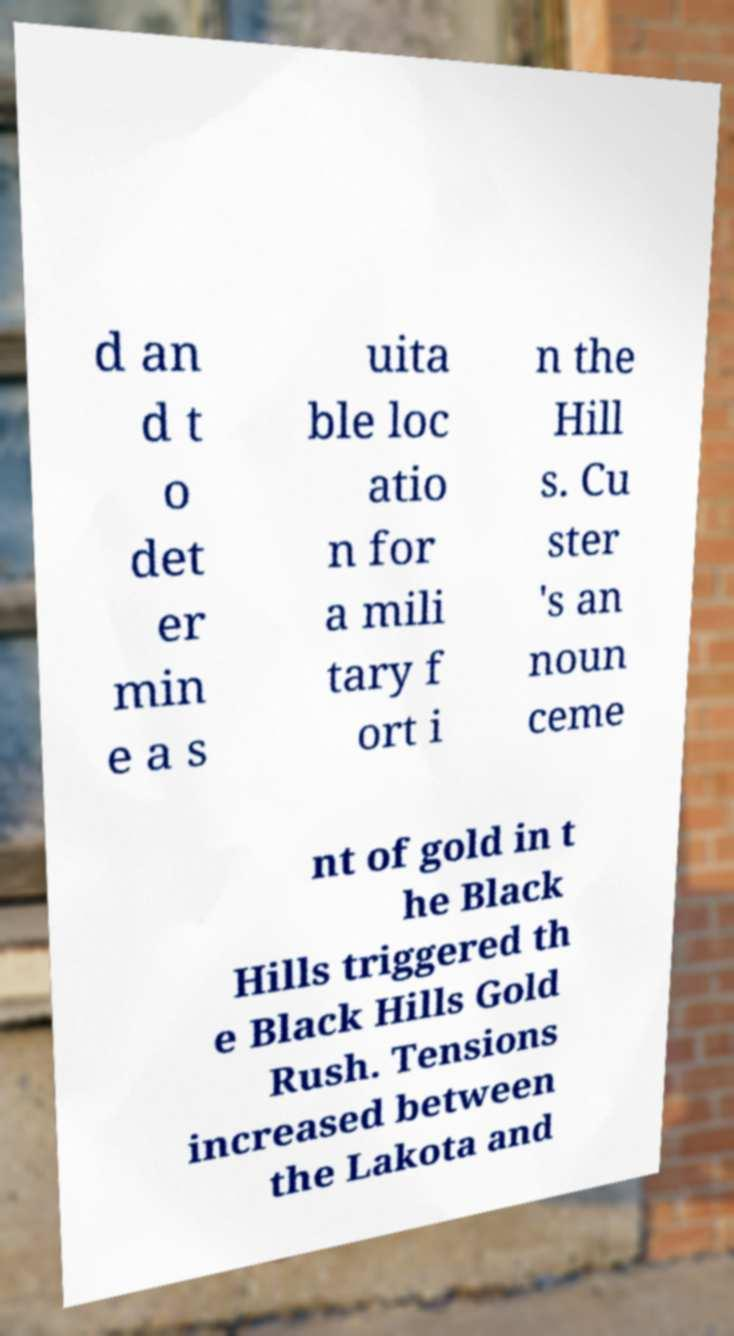There's text embedded in this image that I need extracted. Can you transcribe it verbatim? d an d t o det er min e a s uita ble loc atio n for a mili tary f ort i n the Hill s. Cu ster 's an noun ceme nt of gold in t he Black Hills triggered th e Black Hills Gold Rush. Tensions increased between the Lakota and 